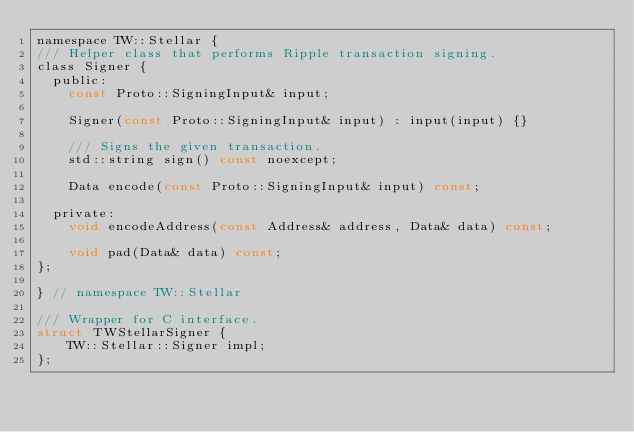Convert code to text. <code><loc_0><loc_0><loc_500><loc_500><_C_>namespace TW::Stellar {
/// Helper class that performs Ripple transaction signing.
class Signer {
  public:
    const Proto::SigningInput& input;

    Signer(const Proto::SigningInput& input) : input(input) {}

    /// Signs the given transaction.
    std::string sign() const noexcept;

    Data encode(const Proto::SigningInput& input) const;

  private:
    void encodeAddress(const Address& address, Data& data) const;

    void pad(Data& data) const;
};

} // namespace TW::Stellar

/// Wrapper for C interface.
struct TWStellarSigner {
    TW::Stellar::Signer impl;
};
</code> 